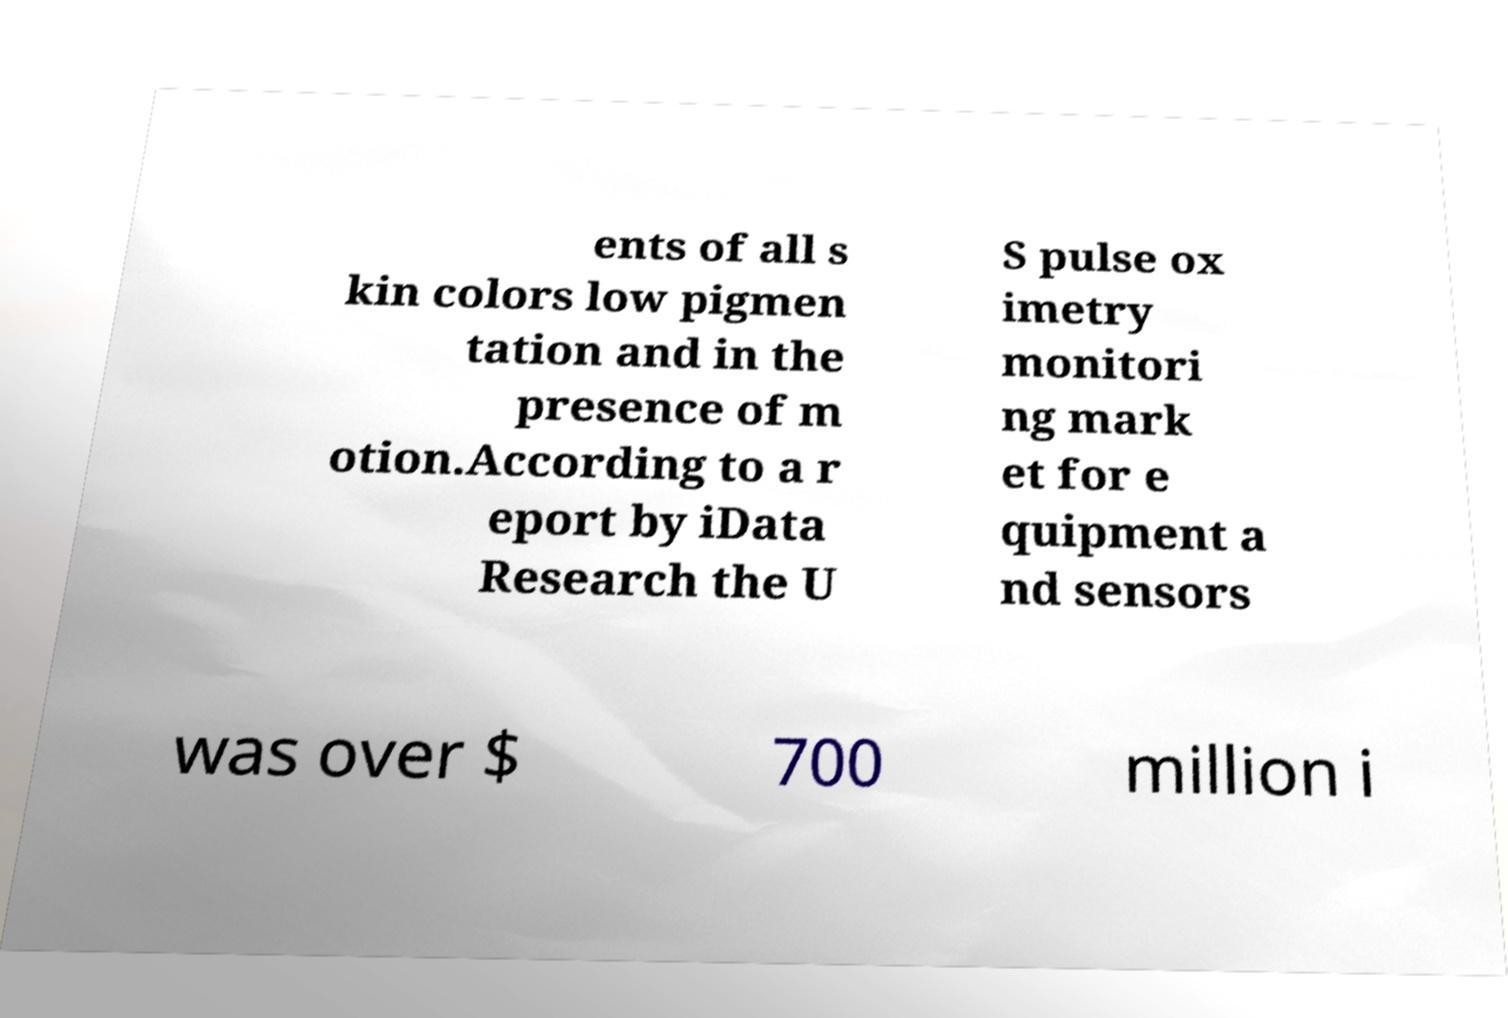For documentation purposes, I need the text within this image transcribed. Could you provide that? ents of all s kin colors low pigmen tation and in the presence of m otion.According to a r eport by iData Research the U S pulse ox imetry monitori ng mark et for e quipment a nd sensors was over $ 700 million i 